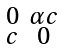<formula> <loc_0><loc_0><loc_500><loc_500>\begin{smallmatrix} 0 & \alpha c \\ c & 0 \end{smallmatrix}</formula> 